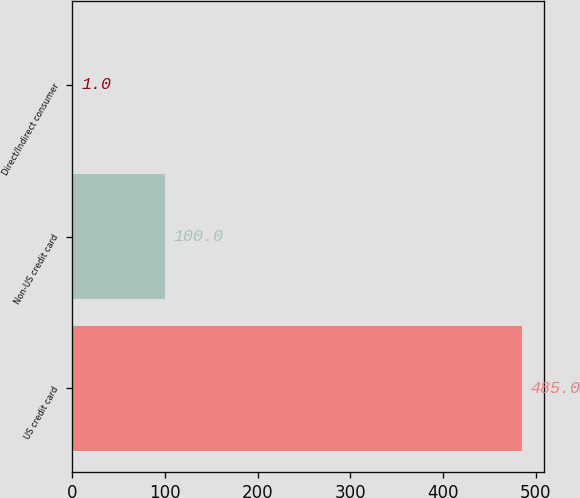Convert chart. <chart><loc_0><loc_0><loc_500><loc_500><bar_chart><fcel>US credit card<fcel>Non-US credit card<fcel>Direct/Indirect consumer<nl><fcel>485<fcel>100<fcel>1<nl></chart> 